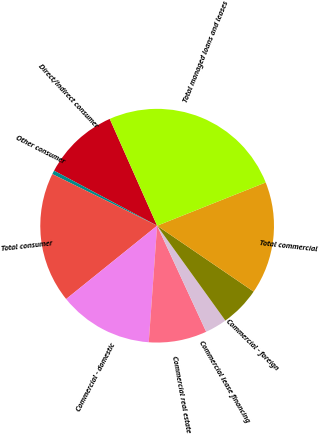Convert chart to OTSL. <chart><loc_0><loc_0><loc_500><loc_500><pie_chart><fcel>Direct/Indirect consumer<fcel>Other consumer<fcel>Total consumer<fcel>Commercial - domestic<fcel>Commercial real estate<fcel>Commercial lease financing<fcel>Commercial - foreign<fcel>Total commercial<fcel>Total managed loans and leases<nl><fcel>10.55%<fcel>0.52%<fcel>18.08%<fcel>13.06%<fcel>8.04%<fcel>3.03%<fcel>5.54%<fcel>15.57%<fcel>25.61%<nl></chart> 